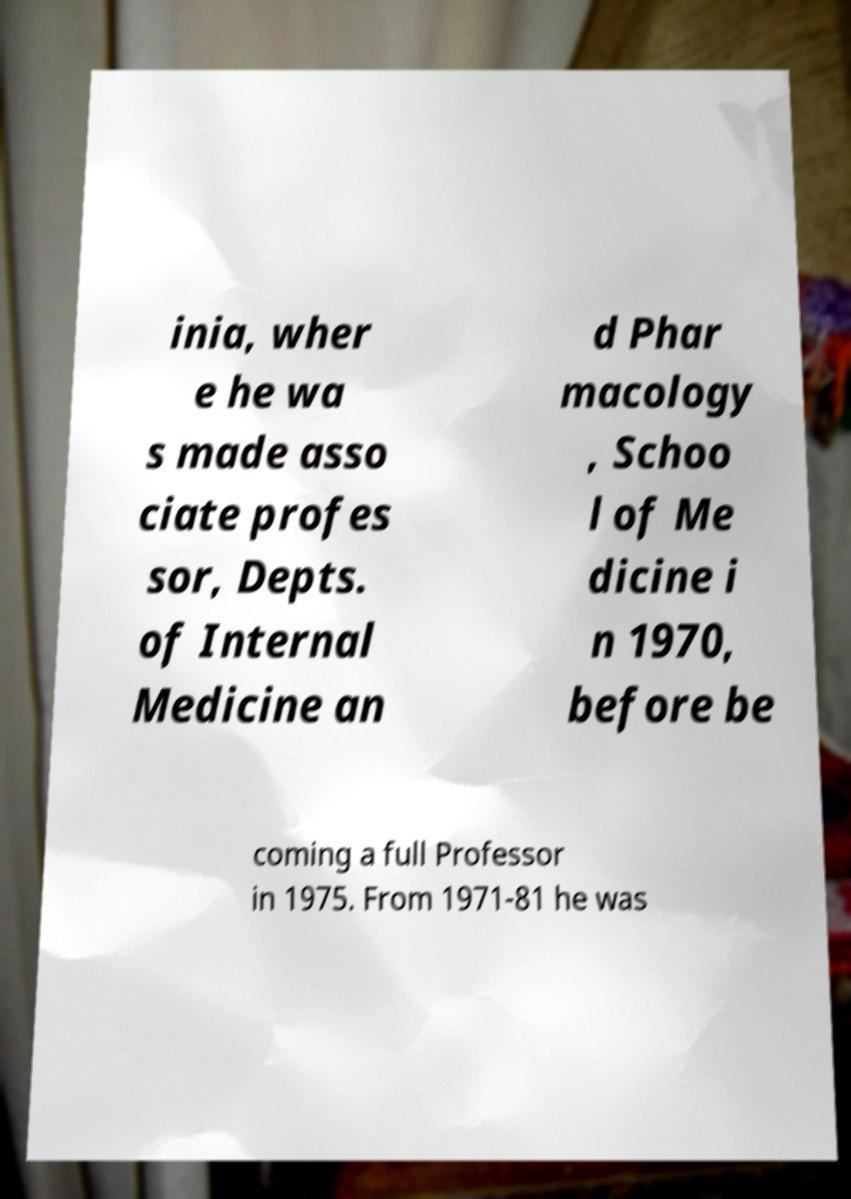I need the written content from this picture converted into text. Can you do that? inia, wher e he wa s made asso ciate profes sor, Depts. of Internal Medicine an d Phar macology , Schoo l of Me dicine i n 1970, before be coming a full Professor in 1975. From 1971-81 he was 